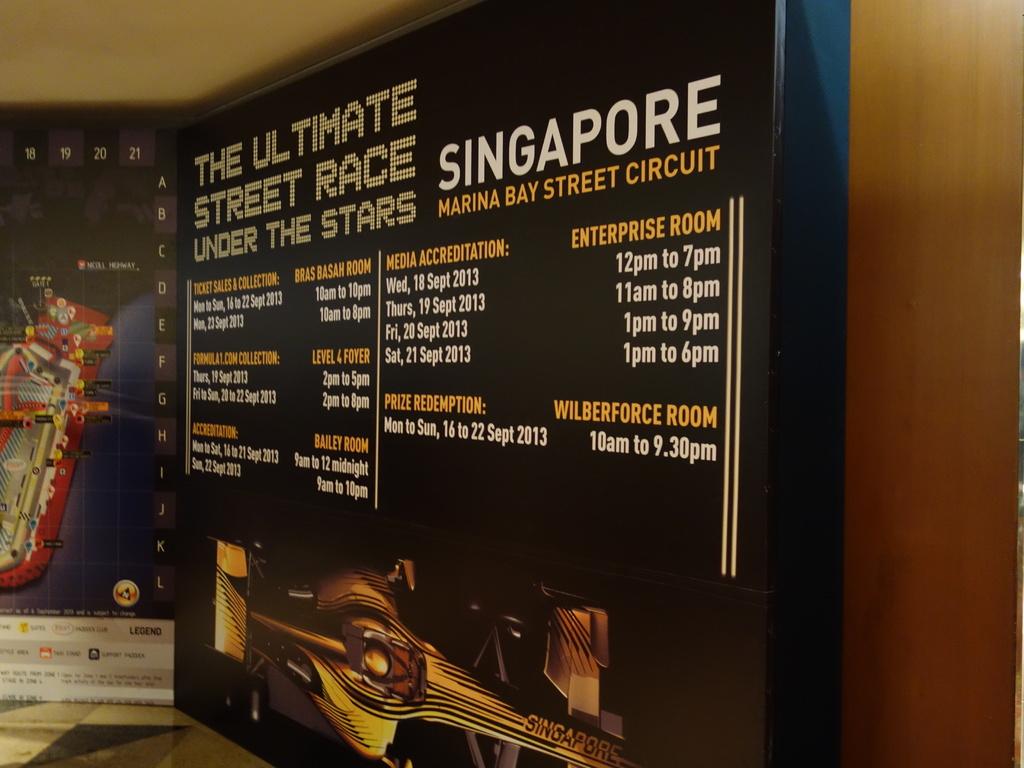What bay circuit is shown?
Make the answer very short. Marina bay street circuit. What is the title of the race?
Offer a very short reply. The ultimate street race under the stars. 